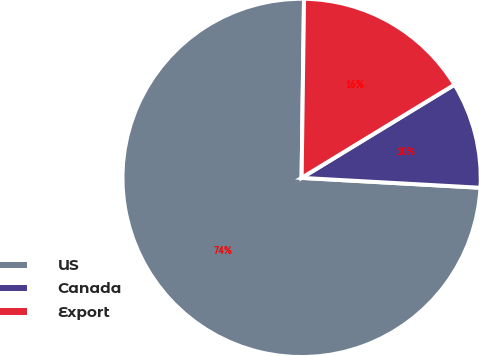<chart> <loc_0><loc_0><loc_500><loc_500><pie_chart><fcel>US<fcel>Canada<fcel>Export<nl><fcel>74.34%<fcel>9.59%<fcel>16.07%<nl></chart> 